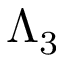<formula> <loc_0><loc_0><loc_500><loc_500>\Lambda _ { 3 }</formula> 